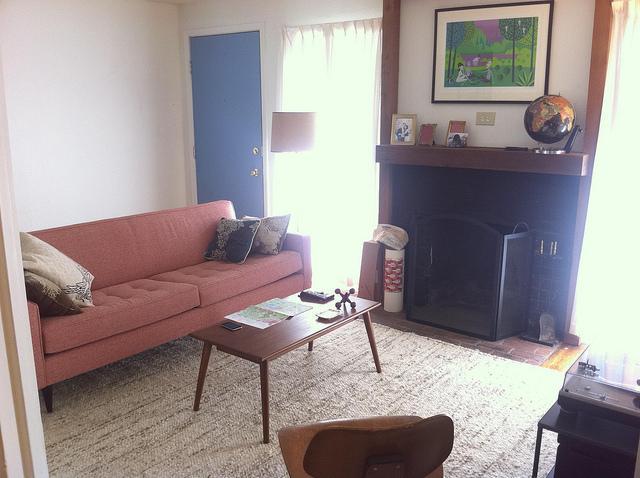How many dump trucks are there?
Give a very brief answer. 0. 